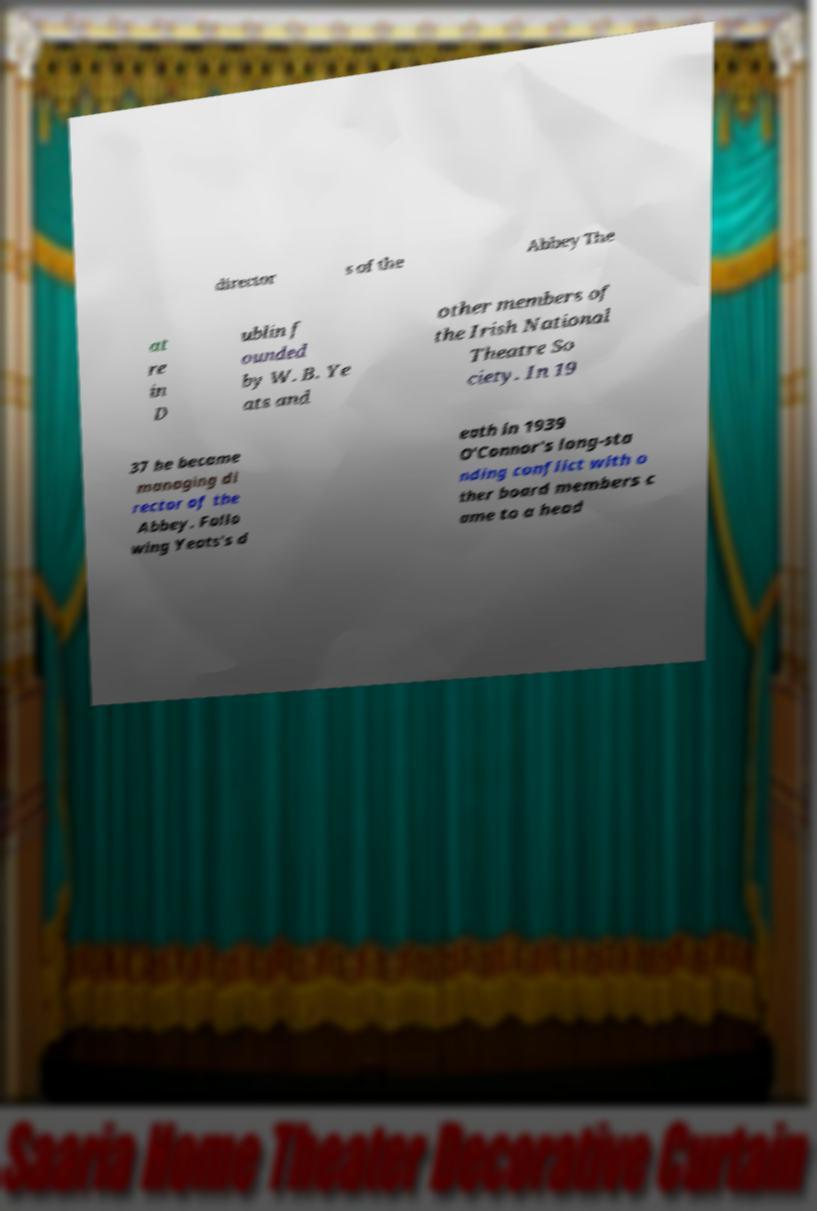Could you extract and type out the text from this image? director s of the Abbey The at re in D ublin f ounded by W. B. Ye ats and other members of the Irish National Theatre So ciety. In 19 37 he became managing di rector of the Abbey. Follo wing Yeats's d eath in 1939 O'Connor's long-sta nding conflict with o ther board members c ame to a head 